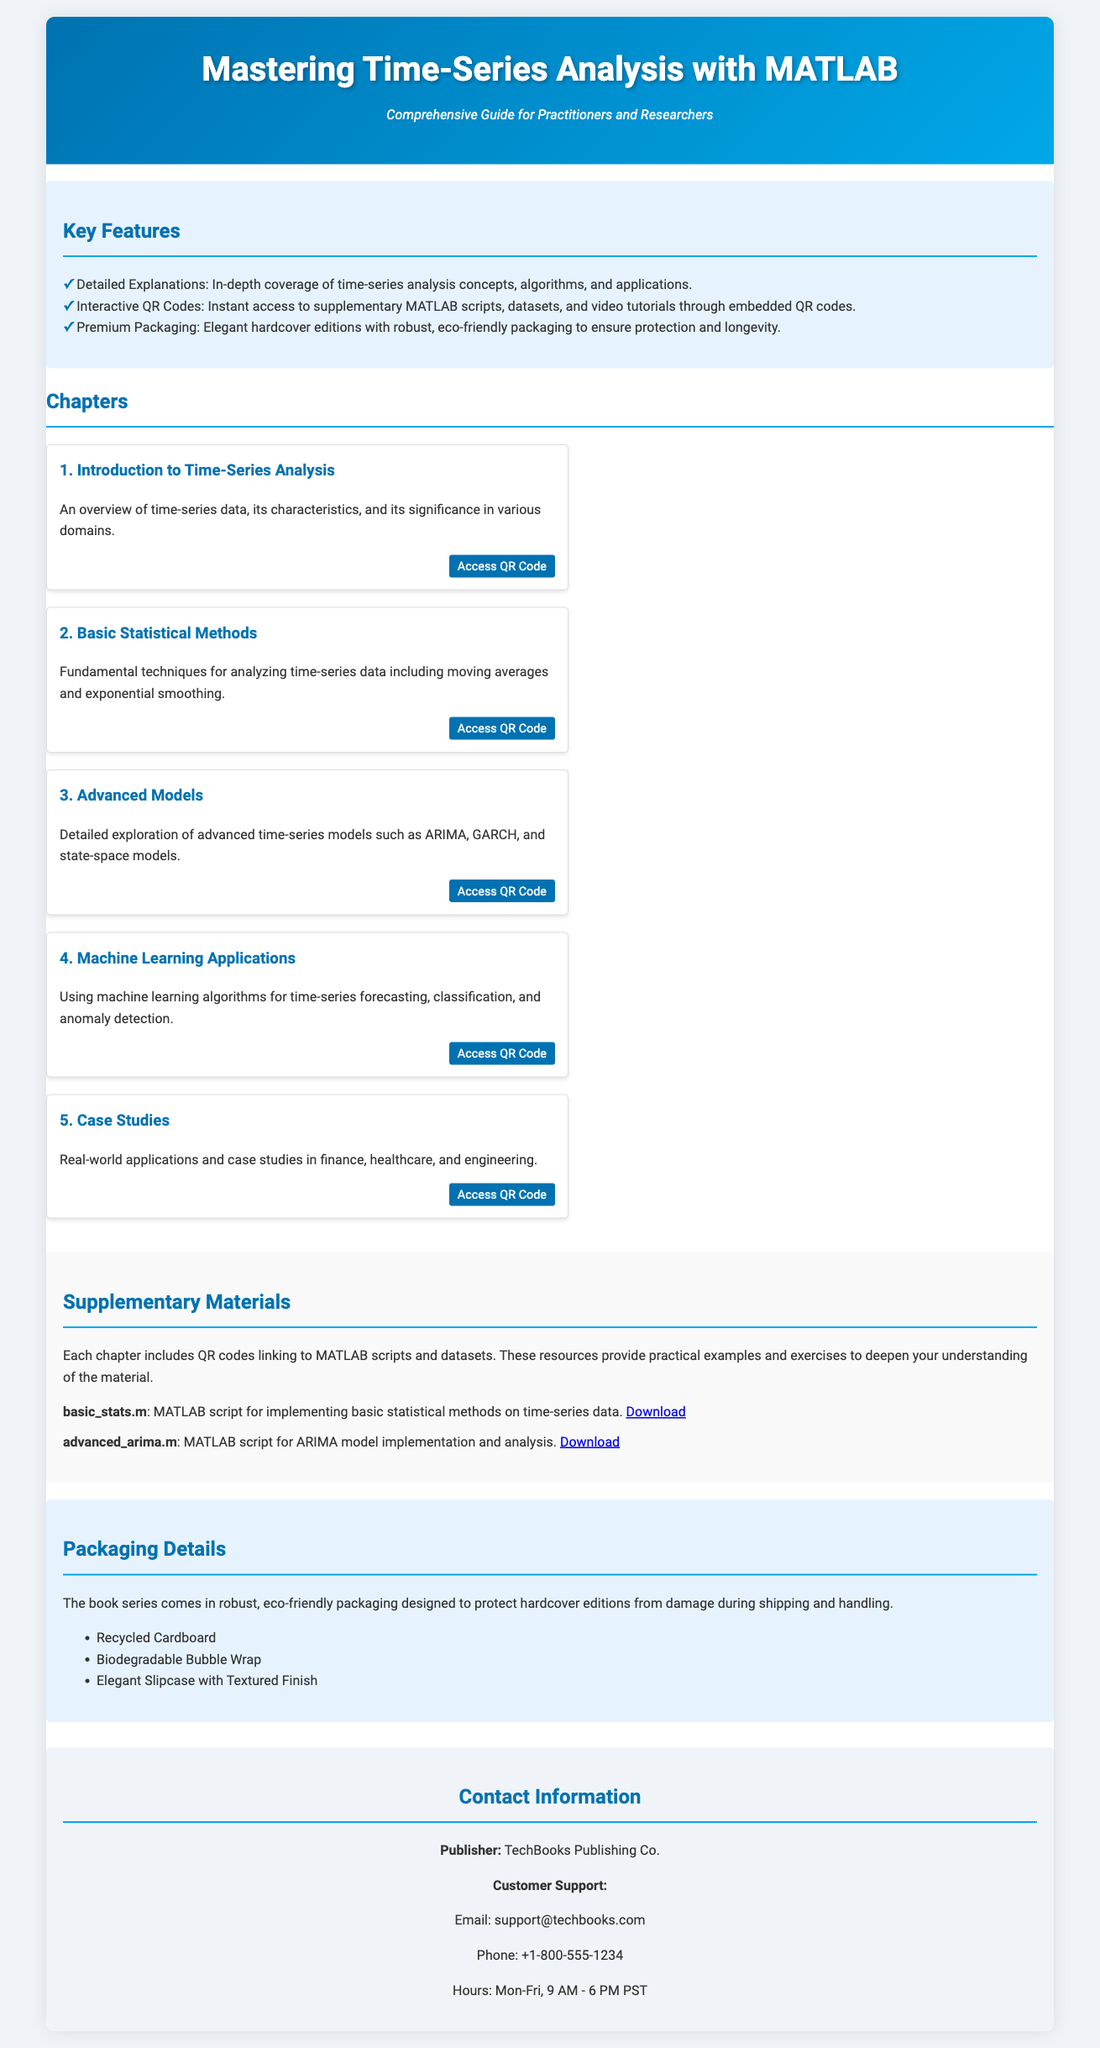what is the title of the book series? The title of the book series is displayed prominently in the header of the document.
Answer: Mastering Time-Series Analysis with MATLAB who is the publisher of the book? The publisher's name is listed in the contact information section of the document.
Answer: TechBooks Publishing Co how many chapters are in the book series? The number of chapters can be counted from the chapters section of the document.
Answer: Five what type of packaging is used for the hardcover editions? The packaging details section describes the type of packaging used for the books.
Answer: Eco-friendly packaging what is one of the supplementary materials available? The supplementary materials section lists specific MATLAB scripts provided for each chapter.
Answer: basic_stats.m what is the first chapter about? The description for the first chapter is found in the chapters section of the document.
Answer: Introduction to Time-Series Analysis how can you access supplementary MATLAB scripts? The features section mentions a method for accessing supplementary materials related to the chapters.
Answer: Interactive QR Codes what is the customer support email provided in the document? The contact information includes specific details about customer support, including email.
Answer: support@techbooks.com 